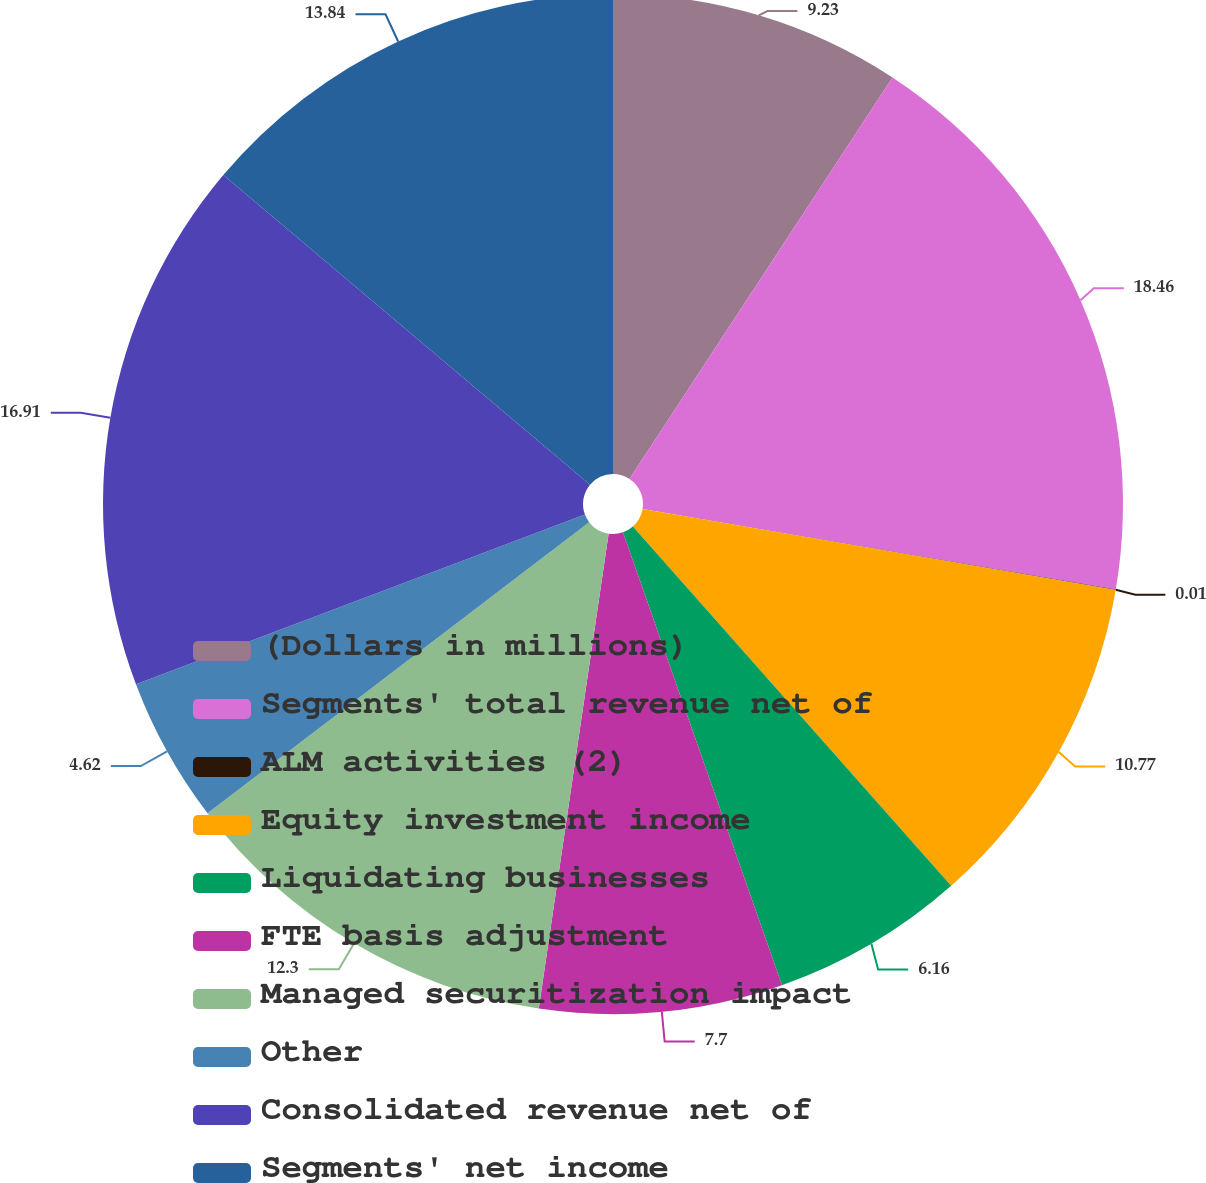Convert chart to OTSL. <chart><loc_0><loc_0><loc_500><loc_500><pie_chart><fcel>(Dollars in millions)<fcel>Segments' total revenue net of<fcel>ALM activities (2)<fcel>Equity investment income<fcel>Liquidating businesses<fcel>FTE basis adjustment<fcel>Managed securitization impact<fcel>Other<fcel>Consolidated revenue net of<fcel>Segments' net income<nl><fcel>9.23%<fcel>18.45%<fcel>0.01%<fcel>10.77%<fcel>6.16%<fcel>7.7%<fcel>12.3%<fcel>4.62%<fcel>16.91%<fcel>13.84%<nl></chart> 